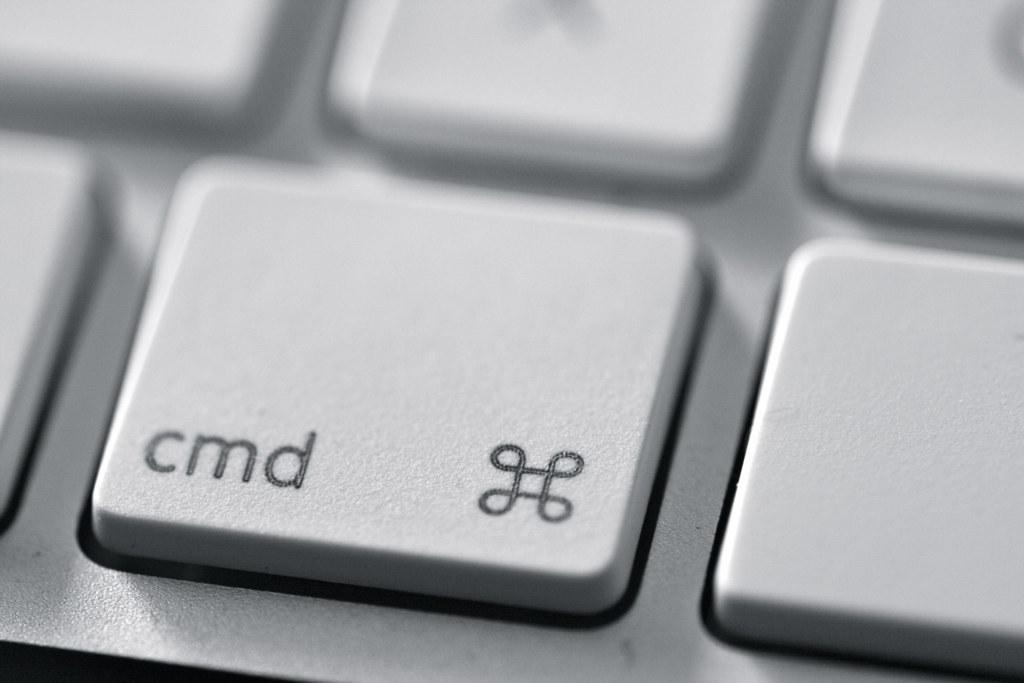What is the main object in the picture? There is a keyboard in the picture. How many keys are on the keyboard? The keyboard has many keys. Is there any text or symbols on the keys? Yes, there is writing on some of the keys. What type of underwear is hanging on the ship in the image? There is no underwear or ship present in the image; it only features a keyboard. How is the stew being prepared on the keyboard in the image? There is no stew or cooking activity depicted in the image; it only features a keyboard with keys. 